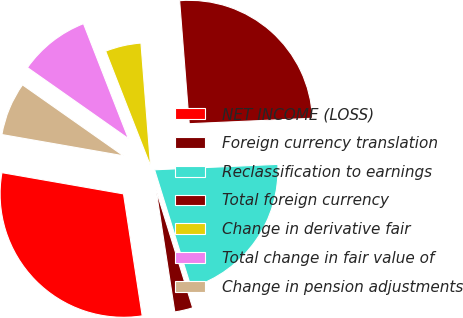Convert chart to OTSL. <chart><loc_0><loc_0><loc_500><loc_500><pie_chart><fcel>NET INCOME (LOSS)<fcel>Foreign currency translation<fcel>Reclassification to earnings<fcel>Total foreign currency<fcel>Change in derivative fair<fcel>Total change in fair value of<fcel>Change in pension adjustments<nl><fcel>30.18%<fcel>2.37%<fcel>20.91%<fcel>25.54%<fcel>4.69%<fcel>9.32%<fcel>7.0%<nl></chart> 